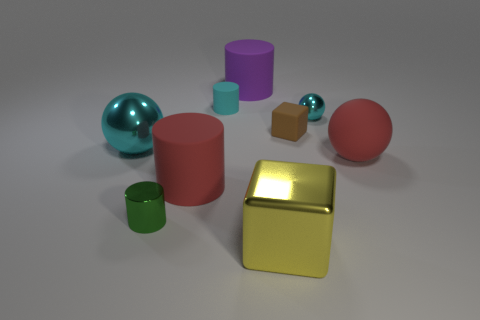Subtract 1 cylinders. How many cylinders are left? 3 Add 1 small green objects. How many objects exist? 10 Subtract all balls. How many objects are left? 6 Subtract all red cylinders. Subtract all cyan metallic spheres. How many objects are left? 6 Add 1 big rubber things. How many big rubber things are left? 4 Add 6 large cyan metal spheres. How many large cyan metal spheres exist? 7 Subtract 0 green spheres. How many objects are left? 9 